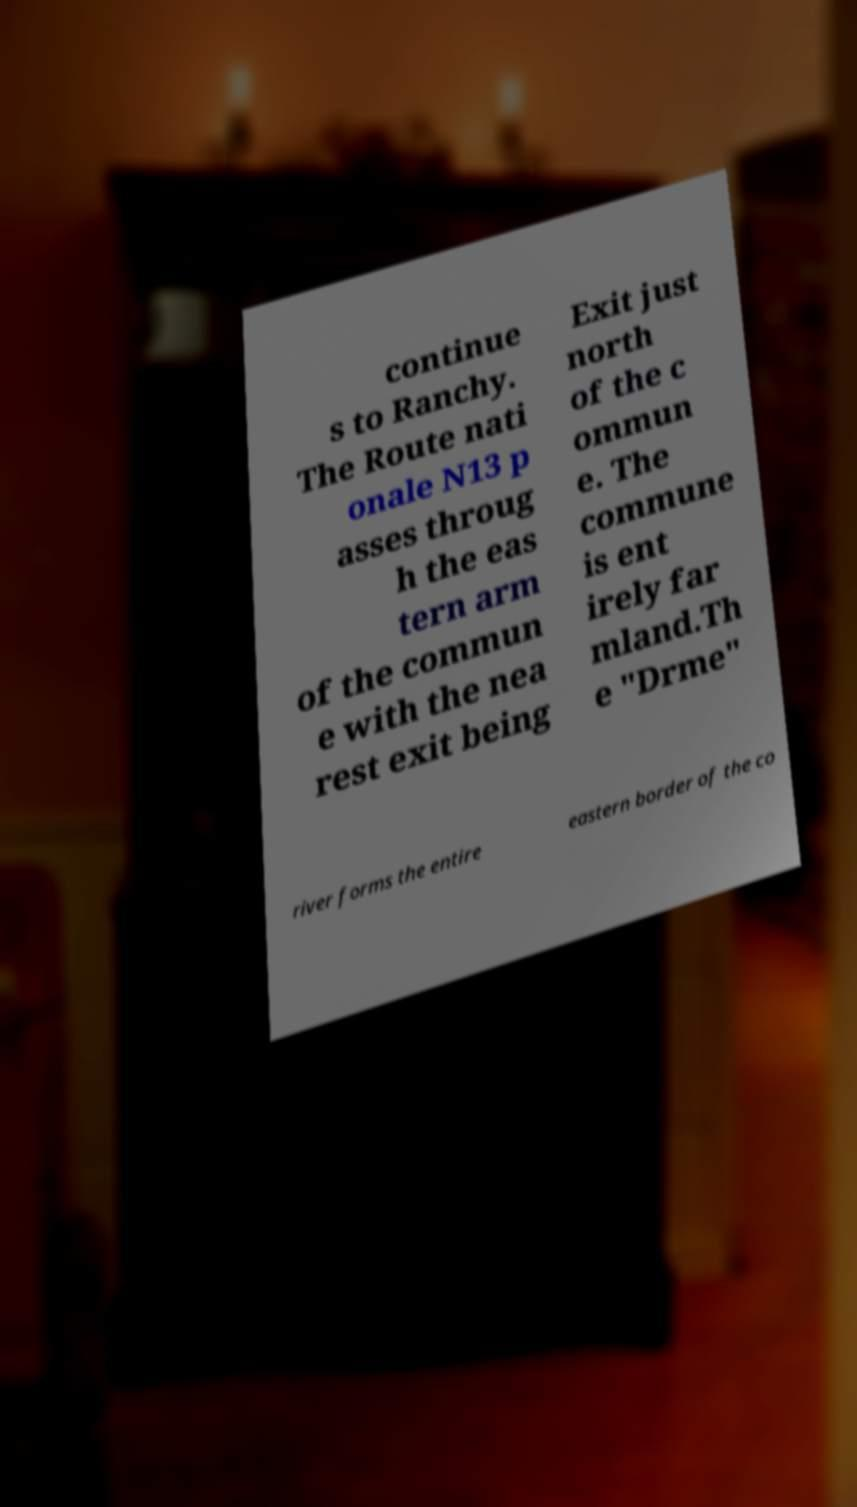Please read and relay the text visible in this image. What does it say? continue s to Ranchy. The Route nati onale N13 p asses throug h the eas tern arm of the commun e with the nea rest exit being Exit just north of the c ommun e. The commune is ent irely far mland.Th e "Drme" river forms the entire eastern border of the co 